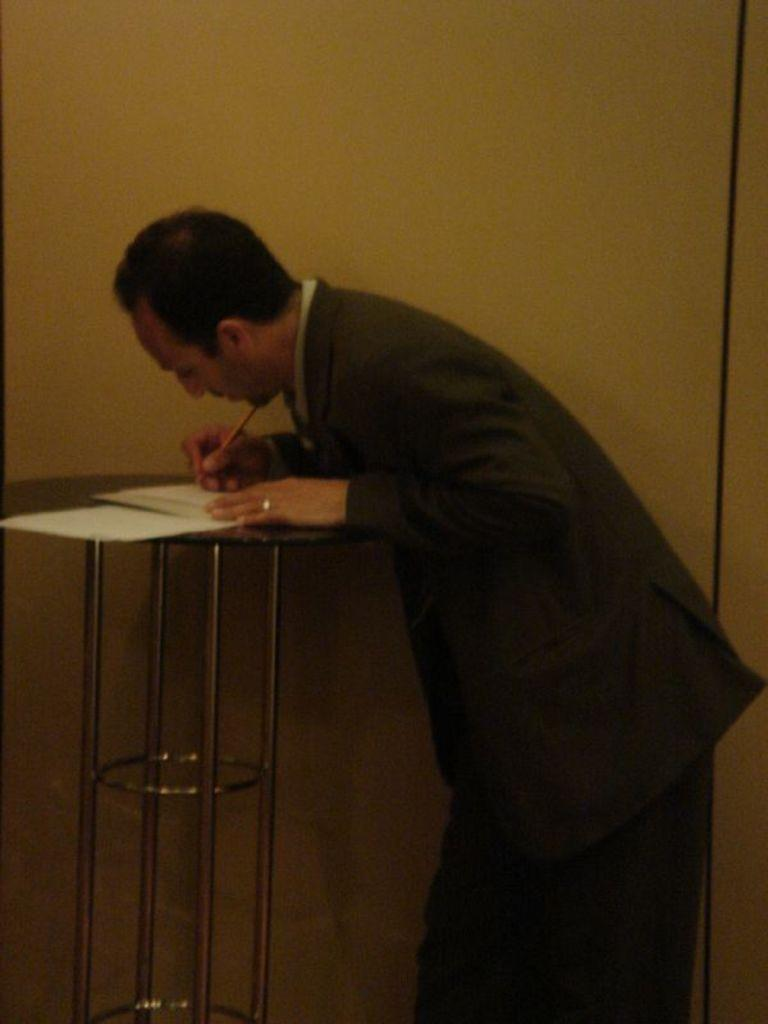Who is present in the image? There is a man in the image. What is the man holding in the image? The man is holding a pen. What objects are on the table in the image? There are papers on a table in the image. What type of weather can be seen in the image? There is no information about the weather in the image, as it only shows a man holding a pen and papers on a table. 